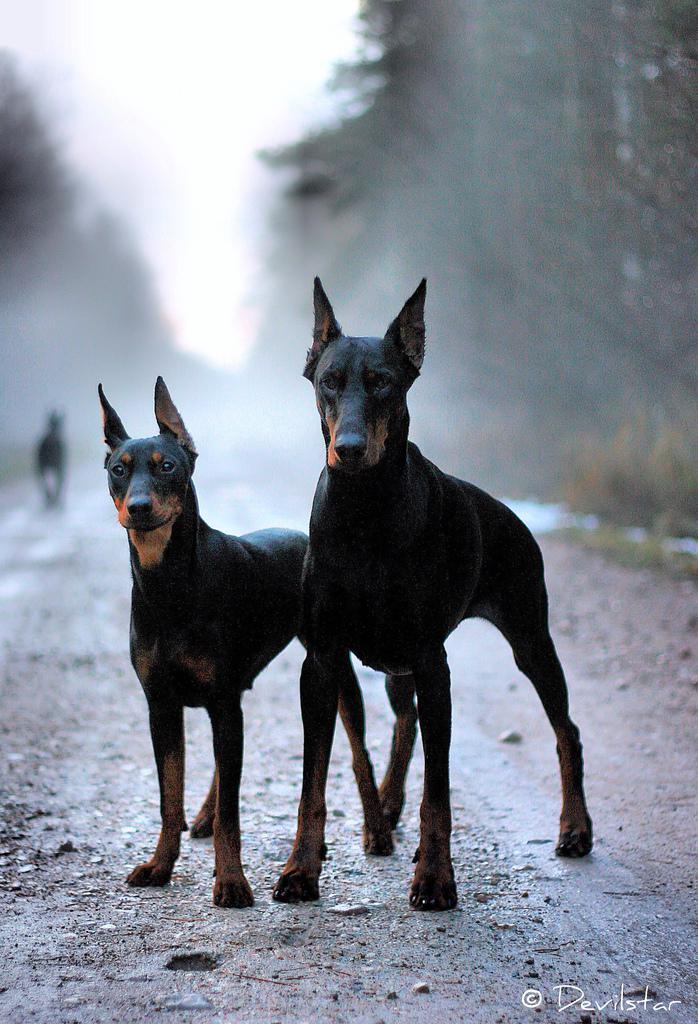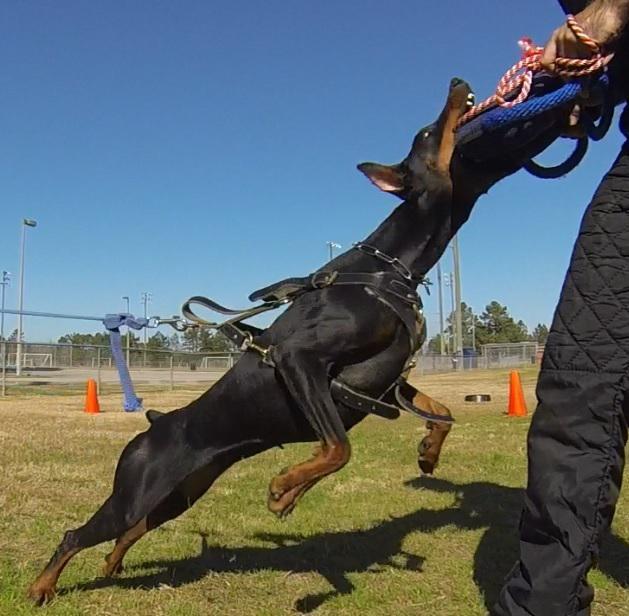The first image is the image on the left, the second image is the image on the right. Examine the images to the left and right. Is the description "The left and right image contains the same number of dogs with one facing forward and the other facing sideways." accurate? Answer yes or no. No. The first image is the image on the left, the second image is the image on the right. Given the left and right images, does the statement "Two dogs are standing." hold true? Answer yes or no. Yes. 